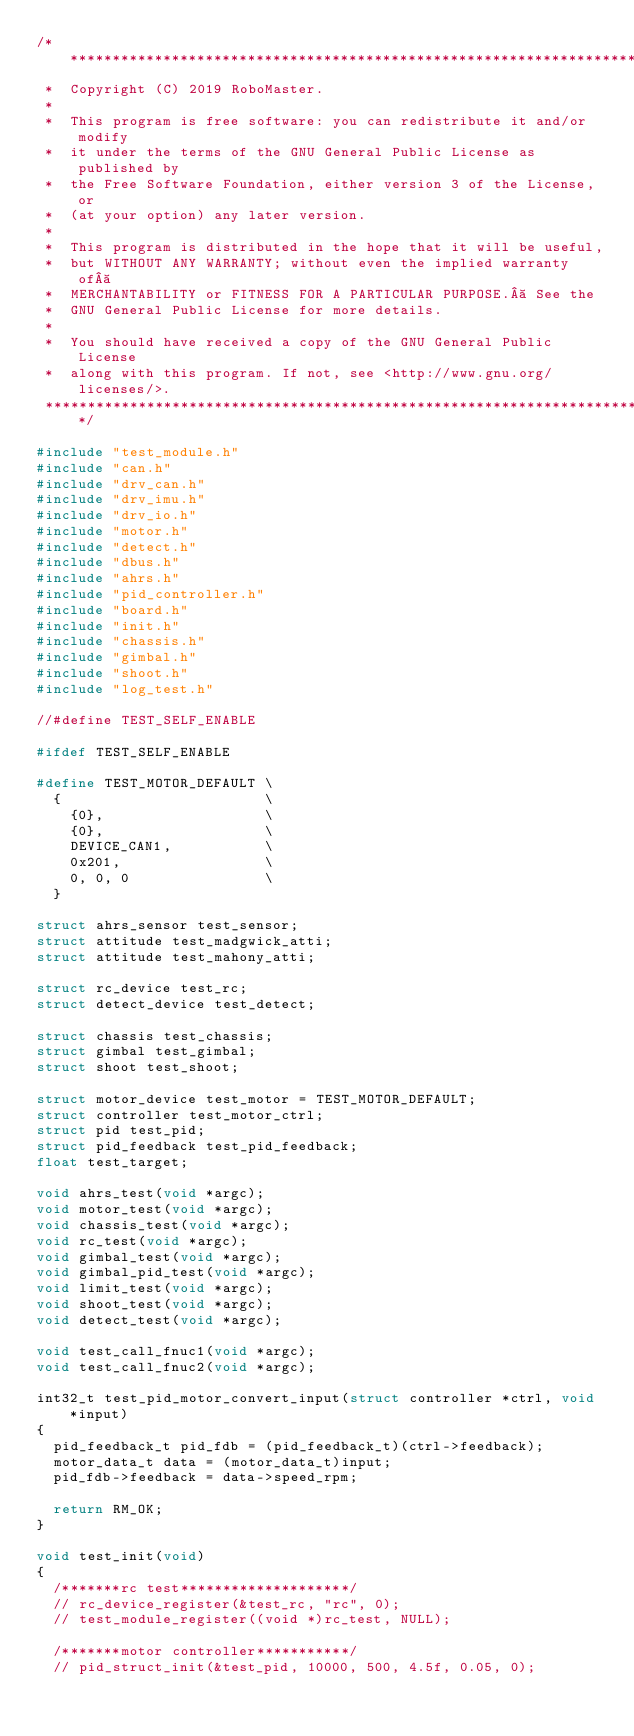<code> <loc_0><loc_0><loc_500><loc_500><_C_>/****************************************************************************
 *  Copyright (C) 2019 RoboMaster.
 *
 *  This program is free software: you can redistribute it and/or modify
 *  it under the terms of the GNU General Public License as published by
 *  the Free Software Foundation, either version 3 of the License, or
 *  (at your option) any later version.
 *
 *  This program is distributed in the hope that it will be useful,
 *  but WITHOUT ANY WARRANTY; without even the implied warranty of 
 *  MERCHANTABILITY or FITNESS FOR A PARTICULAR PURPOSE.  See the
 *  GNU General Public License for more details.
 *
 *  You should have received a copy of the GNU General Public License
 *  along with this program. If not, see <http://www.gnu.org/licenses/>.
 ***************************************************************************/

#include "test_module.h"
#include "can.h"
#include "drv_can.h"
#include "drv_imu.h"
#include "drv_io.h"
#include "motor.h"
#include "detect.h"
#include "dbus.h"
#include "ahrs.h"
#include "pid_controller.h"
#include "board.h"
#include "init.h"
#include "chassis.h"
#include "gimbal.h"
#include "shoot.h"
#include "log_test.h"

//#define TEST_SELF_ENABLE

#ifdef TEST_SELF_ENABLE

#define TEST_MOTOR_DEFAULT \
  {                        \
    {0},                   \
    {0},                   \
    DEVICE_CAN1,           \
    0x201,                 \
    0, 0, 0                \
  }

struct ahrs_sensor test_sensor;
struct attitude test_madgwick_atti;
struct attitude test_mahony_atti;

struct rc_device test_rc;
struct detect_device test_detect;

struct chassis test_chassis;
struct gimbal test_gimbal;
struct shoot test_shoot;

struct motor_device test_motor = TEST_MOTOR_DEFAULT;
struct controller test_motor_ctrl;
struct pid test_pid;
struct pid_feedback test_pid_feedback;
float test_target;

void ahrs_test(void *argc);
void motor_test(void *argc);
void chassis_test(void *argc);
void rc_test(void *argc);
void gimbal_test(void *argc);
void gimbal_pid_test(void *argc);
void limit_test(void *argc);
void shoot_test(void *argc);
void detect_test(void *argc);

void test_call_fnuc1(void *argc);
void test_call_fnuc2(void *argc);

int32_t test_pid_motor_convert_input(struct controller *ctrl, void *input)
{
  pid_feedback_t pid_fdb = (pid_feedback_t)(ctrl->feedback);
  motor_data_t data = (motor_data_t)input;
  pid_fdb->feedback = data->speed_rpm;

  return RM_OK;
}

void test_init(void)
{
  /*******rc test********************/
  // rc_device_register(&test_rc, "rc", 0);
  // test_module_register((void *)rc_test, NULL);

  /*******motor controller***********/
  // pid_struct_init(&test_pid, 10000, 500, 4.5f, 0.05, 0);</code> 